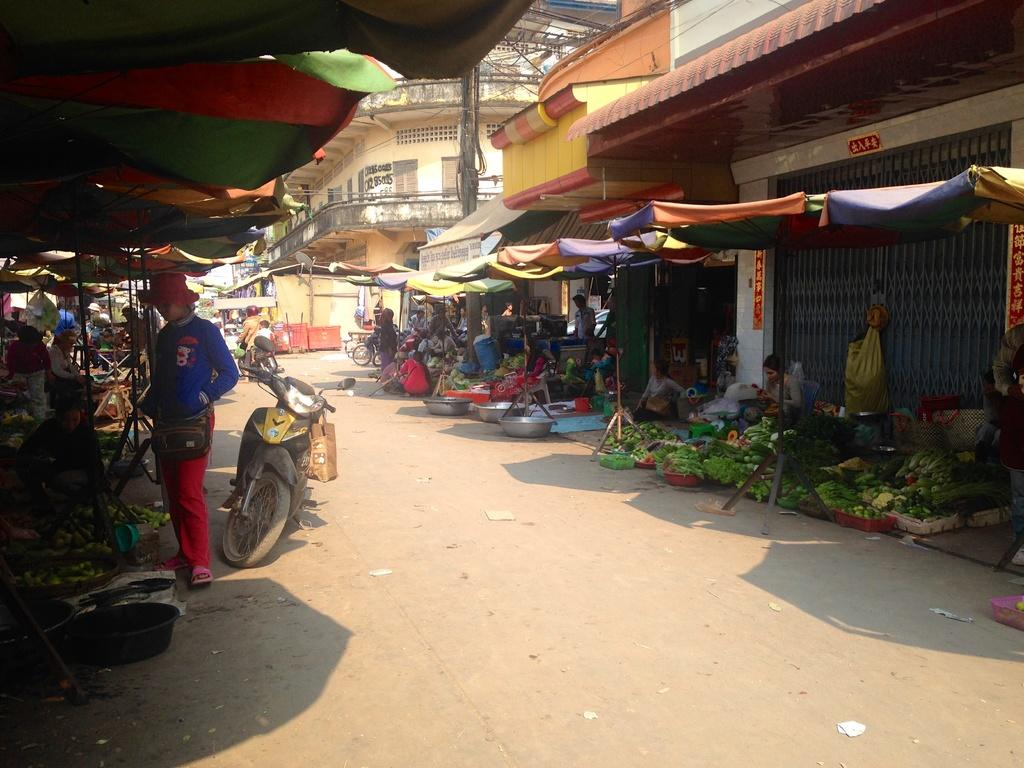What type of stalls can be seen in the image? There are vegetable stalls in the image. What is providing shelter for the stalls? The stalls are under tents. Are there any people present in the image? Yes, there are persons in the image. What else can be seen in the image besides the stalls and people? There are vehicles in the image. What is visible in the background of the image? Buildings are visible behind the tents. What type of error can be seen on the face of the person in the image? There is no error visible on the face of any person in the image. What is the person holding in the image? The provided facts do not mention any person holding a sack or any other object. 